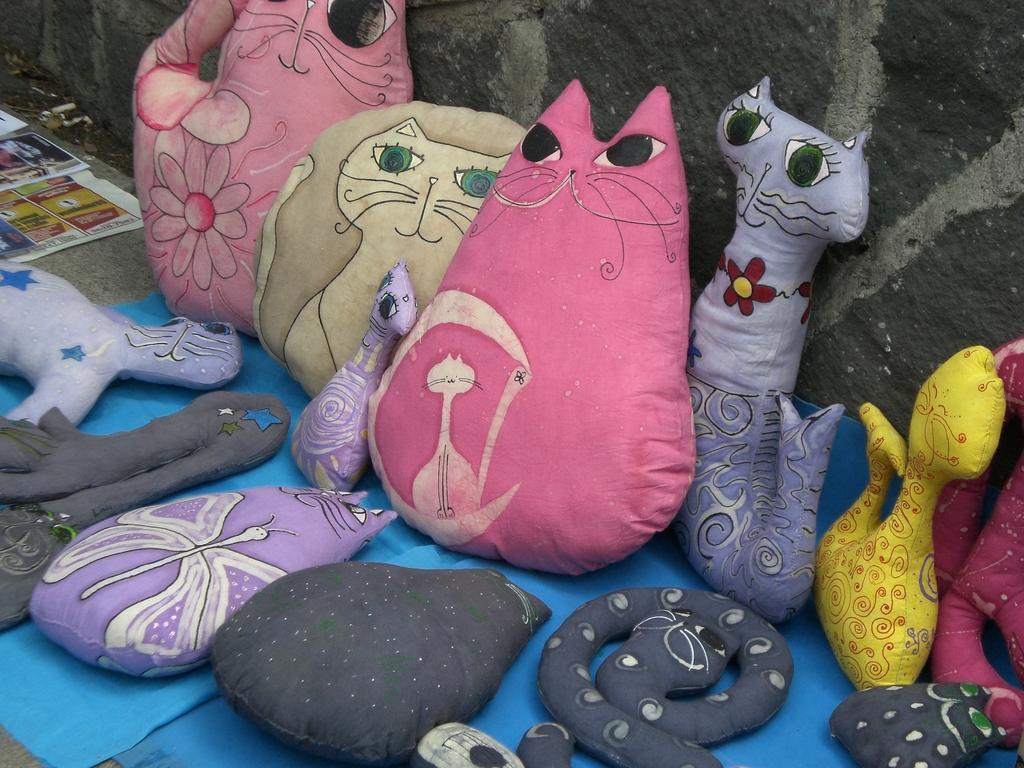In one or two sentences, can you explain what this image depicts? In the center of the image there are soft toys. In the background of the image there is wall. To the left side of the image there is paper. 